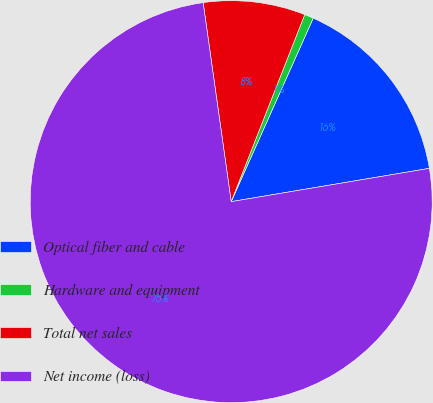<chart> <loc_0><loc_0><loc_500><loc_500><pie_chart><fcel>Optical fiber and cable<fcel>Hardware and equipment<fcel>Total net sales<fcel>Net income (loss)<nl><fcel>15.66%<fcel>0.73%<fcel>8.19%<fcel>75.42%<nl></chart> 